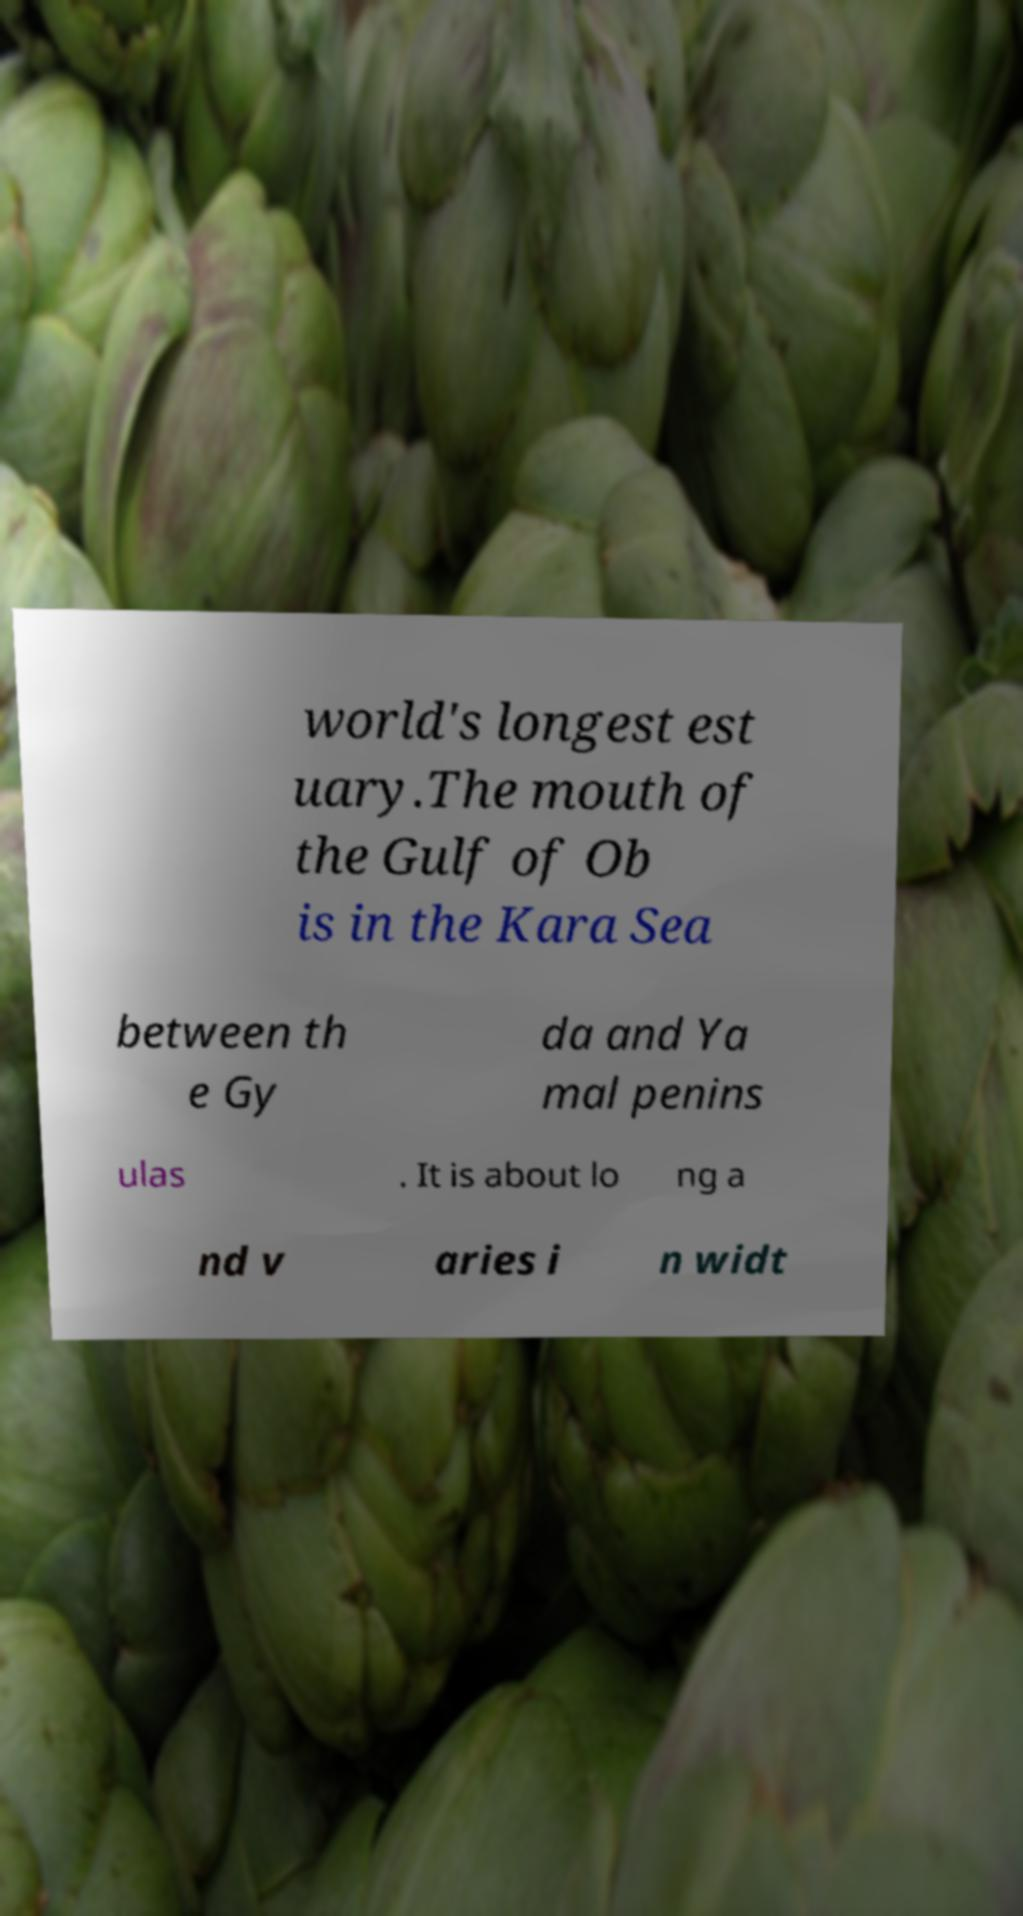Could you assist in decoding the text presented in this image and type it out clearly? world's longest est uary.The mouth of the Gulf of Ob is in the Kara Sea between th e Gy da and Ya mal penins ulas . It is about lo ng a nd v aries i n widt 